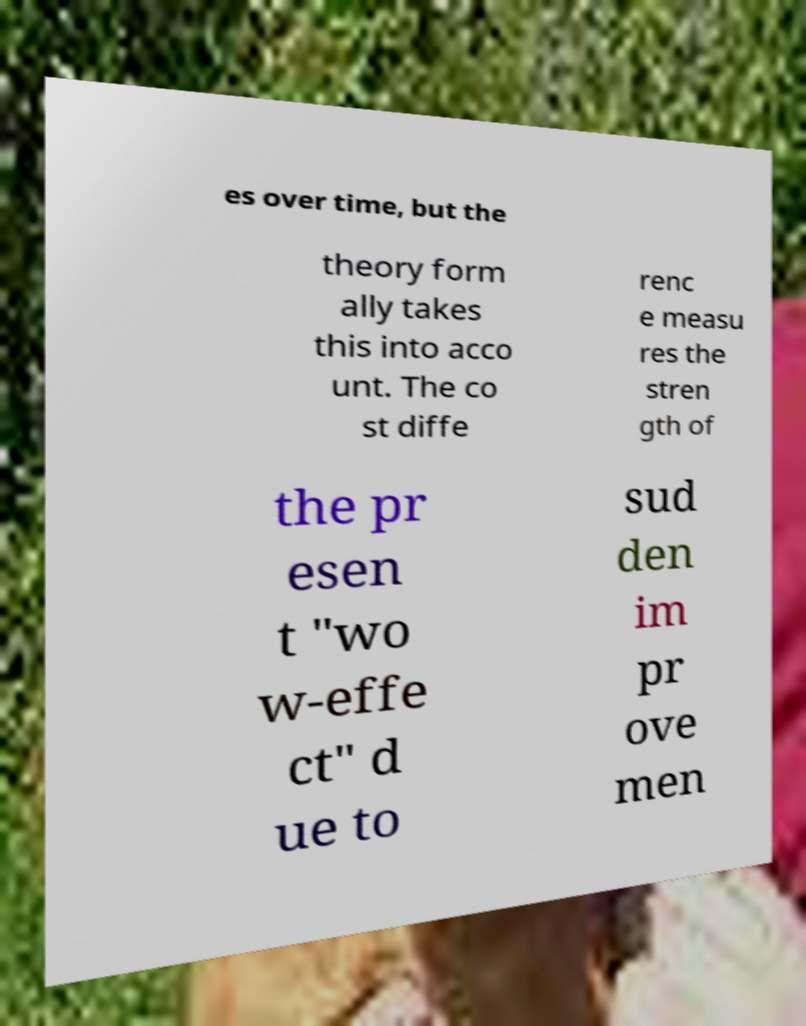Could you assist in decoding the text presented in this image and type it out clearly? es over time, but the theory form ally takes this into acco unt. The co st diffe renc e measu res the stren gth of the pr esen t "wo w-effe ct" d ue to sud den im pr ove men 